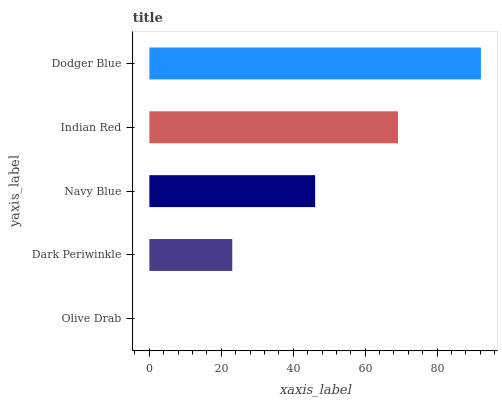Is Olive Drab the minimum?
Answer yes or no. Yes. Is Dodger Blue the maximum?
Answer yes or no. Yes. Is Dark Periwinkle the minimum?
Answer yes or no. No. Is Dark Periwinkle the maximum?
Answer yes or no. No. Is Dark Periwinkle greater than Olive Drab?
Answer yes or no. Yes. Is Olive Drab less than Dark Periwinkle?
Answer yes or no. Yes. Is Olive Drab greater than Dark Periwinkle?
Answer yes or no. No. Is Dark Periwinkle less than Olive Drab?
Answer yes or no. No. Is Navy Blue the high median?
Answer yes or no. Yes. Is Navy Blue the low median?
Answer yes or no. Yes. Is Indian Red the high median?
Answer yes or no. No. Is Dark Periwinkle the low median?
Answer yes or no. No. 